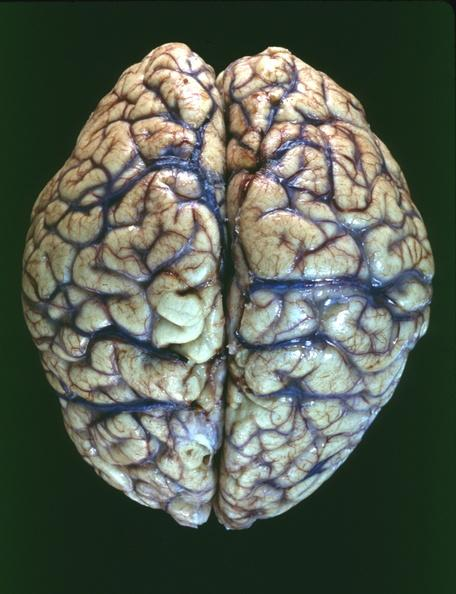s nervous present?
Answer the question using a single word or phrase. Yes 